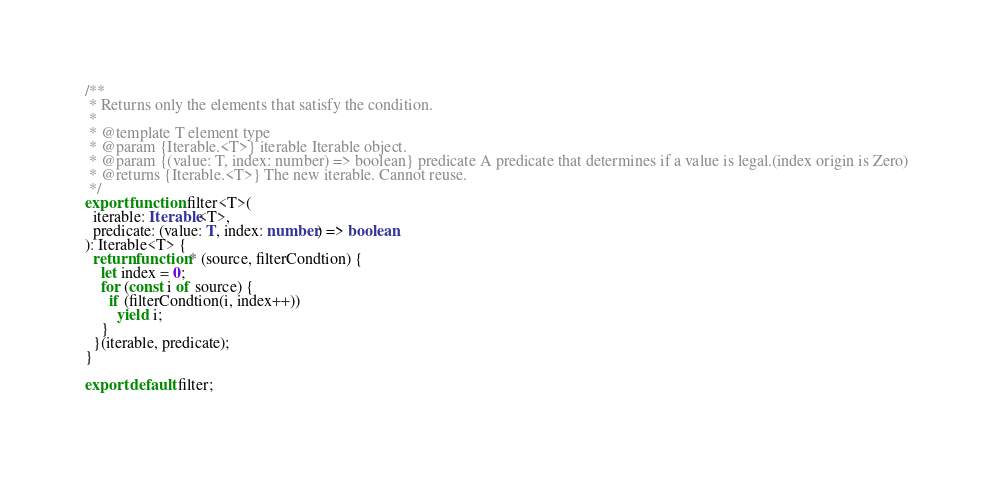<code> <loc_0><loc_0><loc_500><loc_500><_TypeScript_>/**
 * Returns only the elements that satisfy the condition.
 *
 * @template T element type
 * @param {Iterable.<T>} iterable Iterable object.
 * @param {(value: T, index: number) => boolean} predicate A predicate that determines if a value is legal.(index origin is Zero)
 * @returns {Iterable.<T>} The new iterable. Cannot reuse.
 */
export function filter<T>(
  iterable: Iterable<T>,
  predicate: (value: T, index: number) => boolean
): Iterable<T> {
  return function* (source, filterCondtion) {
    let index = 0;
    for (const i of source) {
      if (filterCondtion(i, index++))
        yield i;
    }
  }(iterable, predicate);
}

export default filter;
</code> 